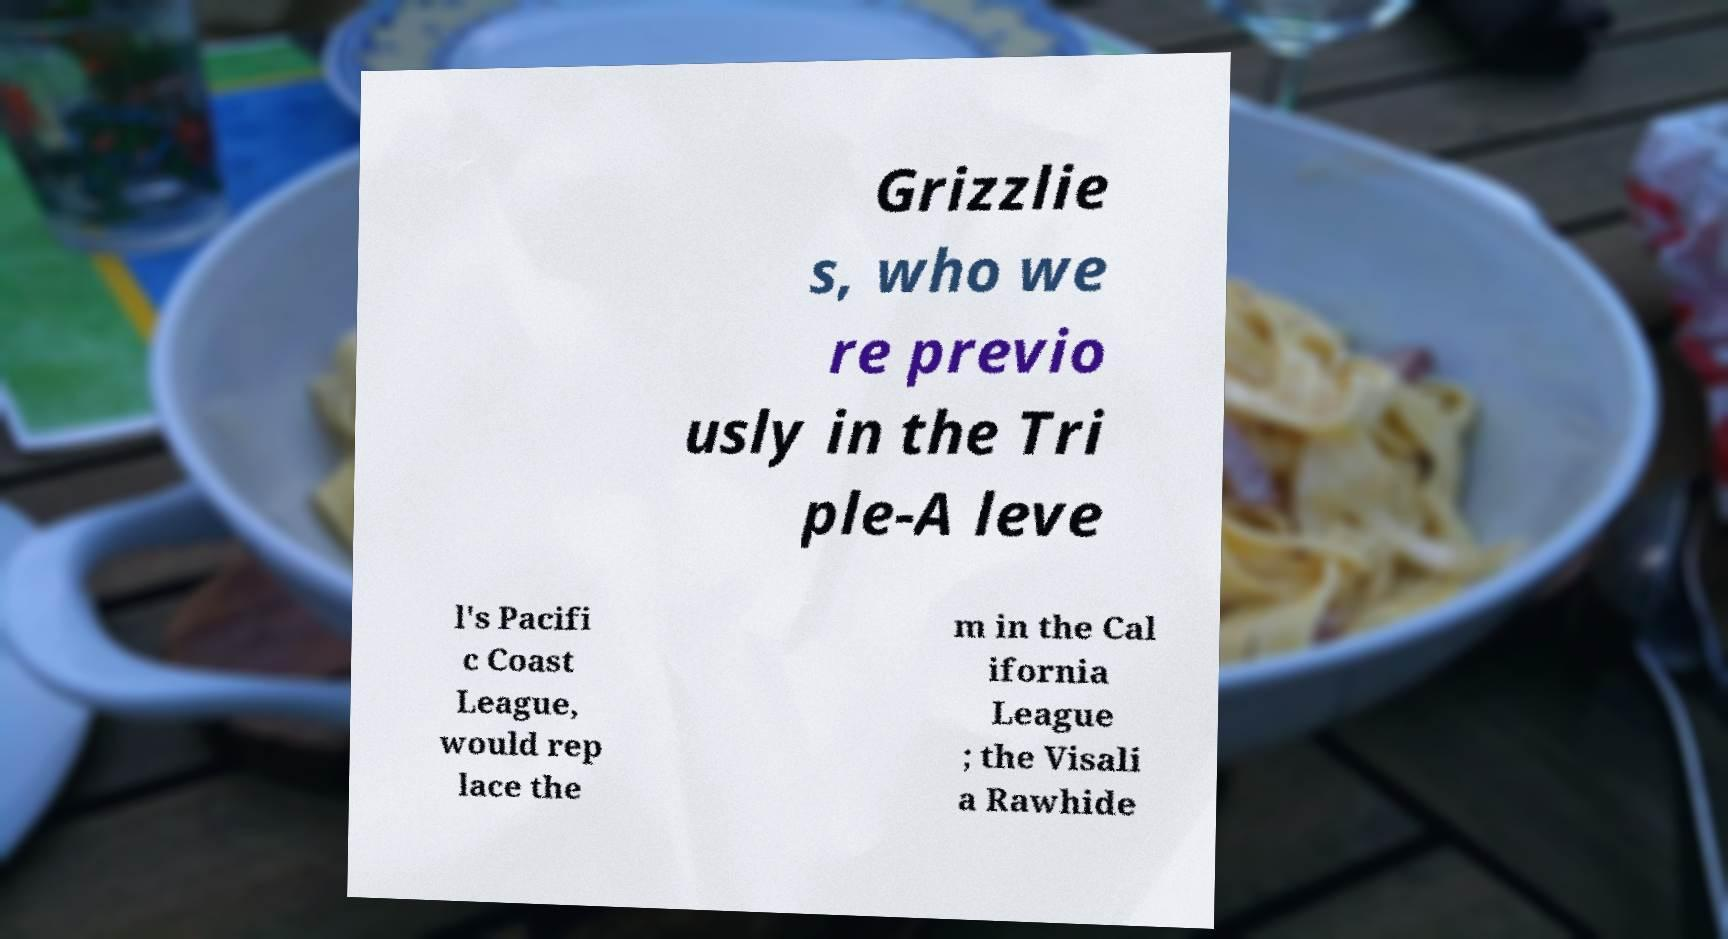There's text embedded in this image that I need extracted. Can you transcribe it verbatim? Grizzlie s, who we re previo usly in the Tri ple-A leve l's Pacifi c Coast League, would rep lace the m in the Cal ifornia League ; the Visali a Rawhide 